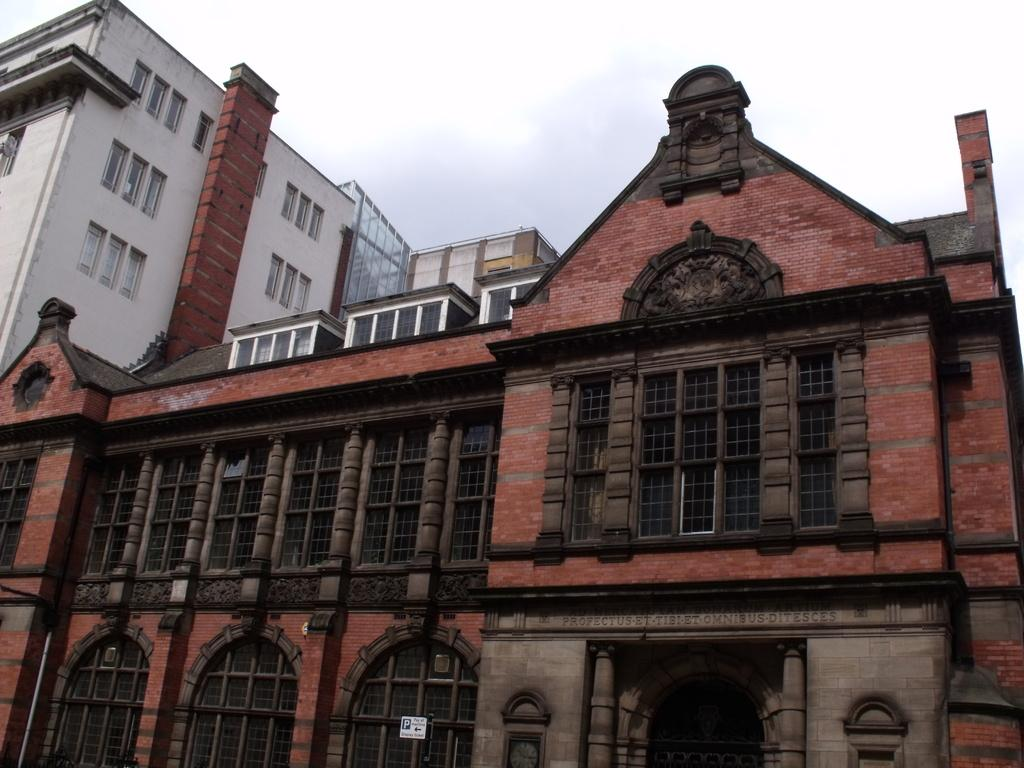What type of structure is present in the image? There is a building in the image. What is the color of the bricks used in the building? The building has red color bricks. What can be seen at the top of the image? The sky is visible at the top of the image. How many lamps are hanging from the building in the image? There are no lamps visible in the image; it only shows a building with red color bricks and the sky. 